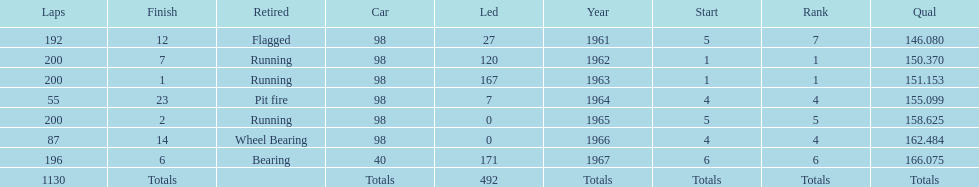Over how many uninterrupted years did parnelli secure a spot in the top 5? 5. 